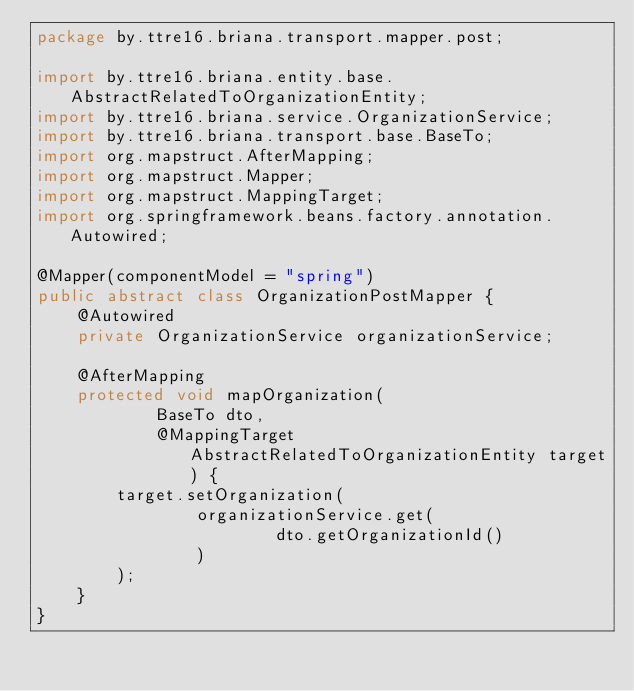<code> <loc_0><loc_0><loc_500><loc_500><_Java_>package by.ttre16.briana.transport.mapper.post;

import by.ttre16.briana.entity.base.AbstractRelatedToOrganizationEntity;
import by.ttre16.briana.service.OrganizationService;
import by.ttre16.briana.transport.base.BaseTo;
import org.mapstruct.AfterMapping;
import org.mapstruct.Mapper;
import org.mapstruct.MappingTarget;
import org.springframework.beans.factory.annotation.Autowired;

@Mapper(componentModel = "spring")
public abstract class OrganizationPostMapper {
    @Autowired
    private OrganizationService organizationService;

    @AfterMapping
    protected void mapOrganization(
            BaseTo dto,
            @MappingTarget AbstractRelatedToOrganizationEntity target) {
        target.setOrganization(
                organizationService.get(
                        dto.getOrganizationId()
                )
        );
    }
}
</code> 